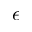Convert formula to latex. <formula><loc_0><loc_0><loc_500><loc_500>\epsilon</formula> 